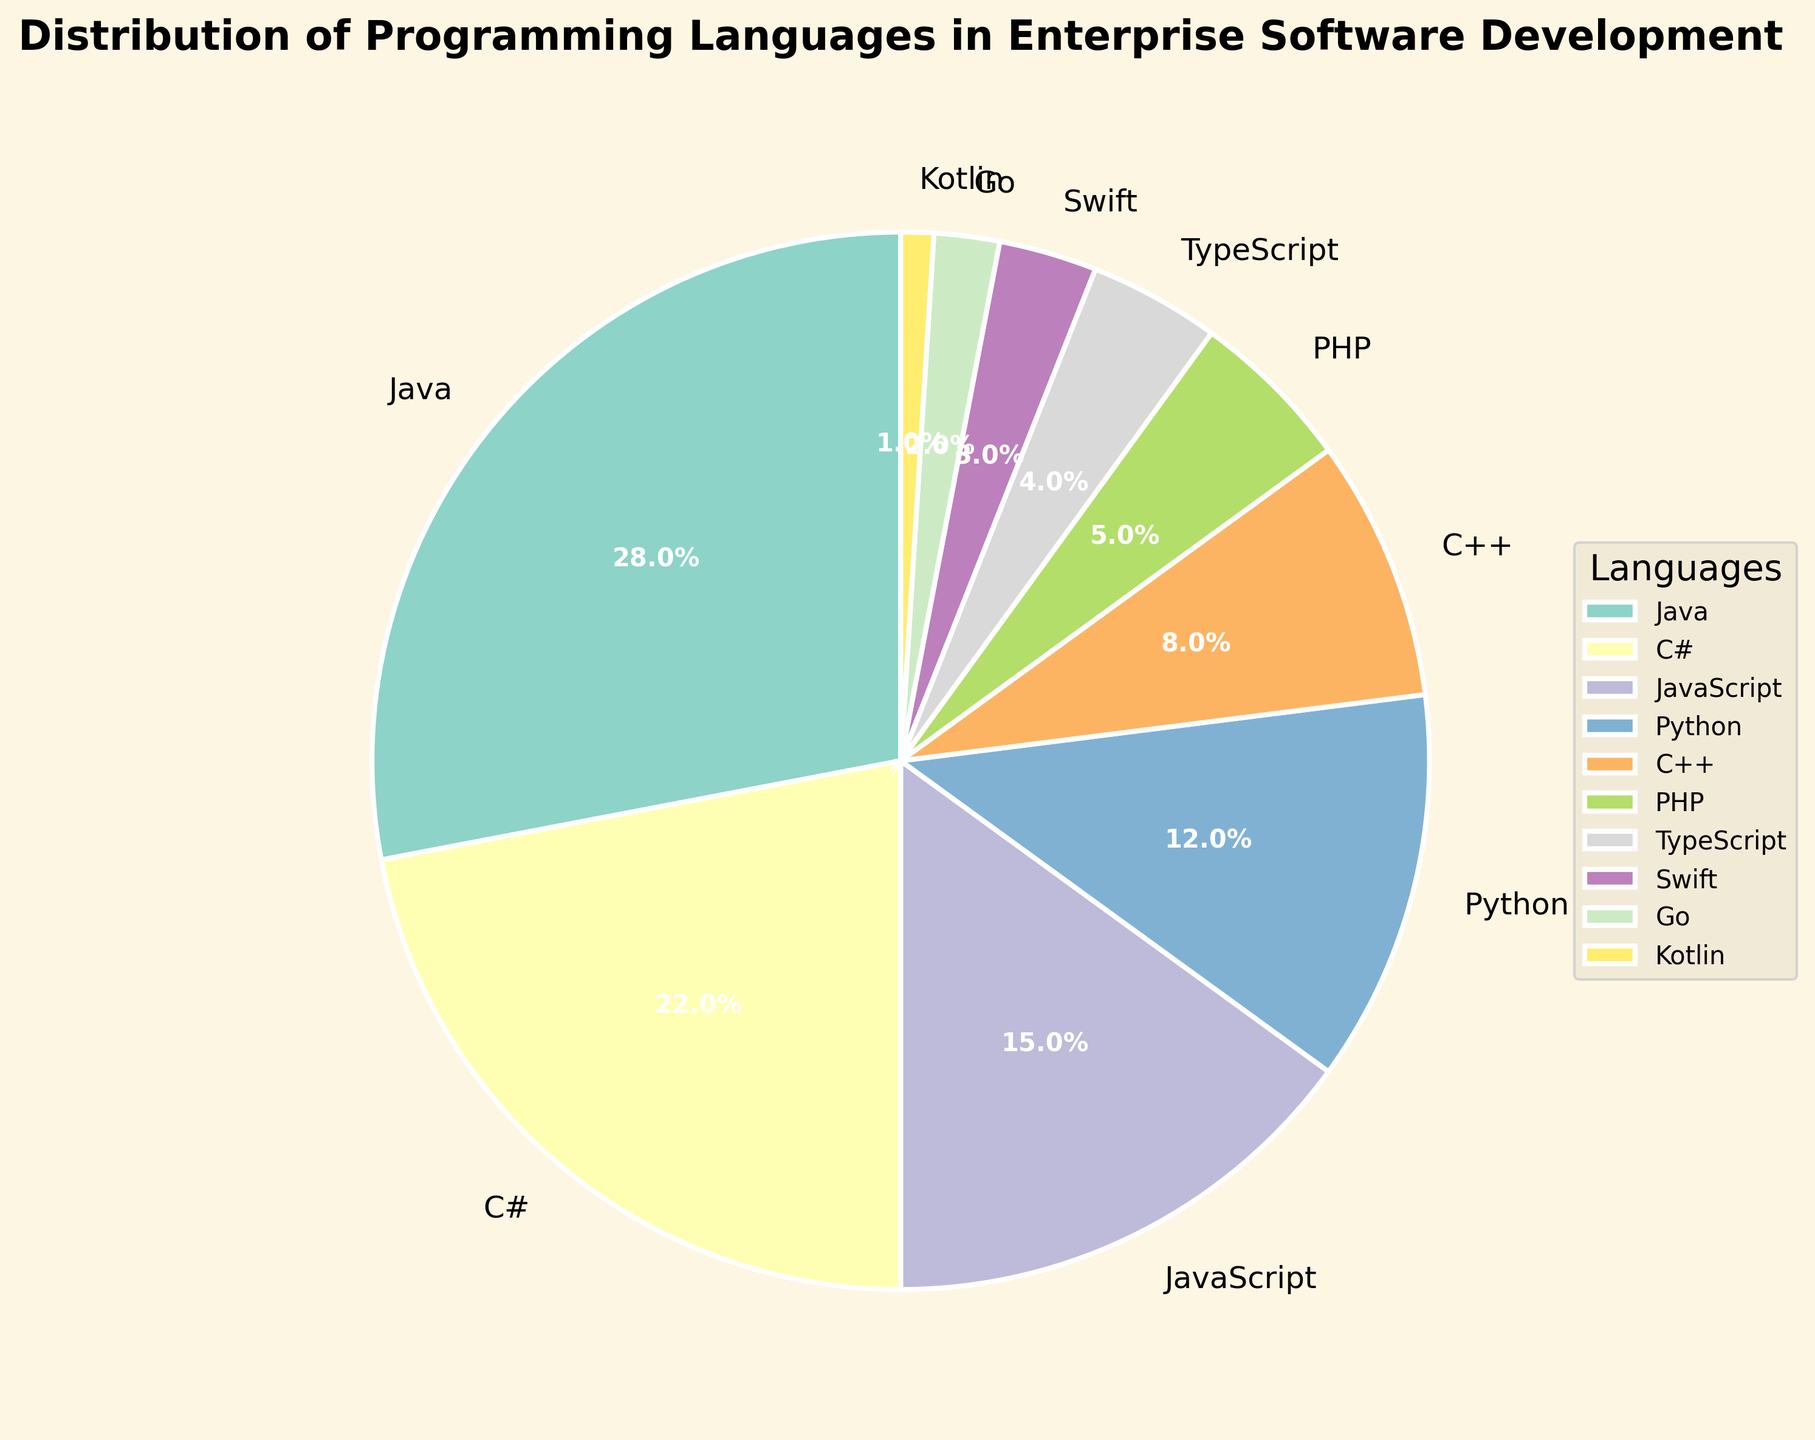What percentage of the distribution is covered by Java and C# combined? The percentages for Java and C# are 28% and 22% respectively. Adding these together, 28% + 22% = 50%
Answer: 50% Which language has the smallest share, and what is that share? Looking at the figure, Kotlin has the smallest share with a percentage of 1%
Answer: Kotlin at 1% Are Python and JavaScript together used more than C#? Python is 12%, and JavaScript is 15%. Adding these together: 12% + 15% = 27%. C# alone is 22%. Since 27% > 22%, Python and JavaScript together are used more than C#
Answer: Yes, 27% vs 22% How does the share of PHP compare to that of Swift and Go combined? PHP is 5%. Swift and Go are 3% and 2% respectively. Adding Swift and Go: 3% + 2% = 5%. Thus, PHP and Swift & Go combined share the same percentage
Answer: Equal Which three languages have the most significant share, and what are their combined percentages? The three languages with the most significant shares are Java (28%), C# (22%), and JavaScript (15%). Combining these: 28% + 22% + 15% = 65%
Answer: Java, C#, JavaScript at 65% If you were to add the shares of Python and C++, would that be more or less than Java? Python is 12%, and C++ is 8%. Adding these together gives 12% + 8% = 20%. Java is 28%, so Python and C++ together would be less than Java
Answer: Less, 20% vs 28% Which slice of the pie has a purple color and what language does it represent? Identifying the colors in the pie chart based on labeling, the slice with purple color could potentially represent Go
Answer: Go How much more is the percentage of Java than TypeScript? Java is 28%, and TypeScript is 4%. Subtracting these gives 28% - 4% = 24%
Answer: 24% What is the total percentage of the languages that are not Java, C#, or JavaScript? The total percentage for all languages is 100%. Excluding Java (28%), C# (22%), and JavaScript (15%), combined these form 28% + 22% + 15% = 65%. Hence, the rest would be 100% - 65% = 35%
Answer: 35% Do PHP and Kotlin together form a higher percentage than C++ alone? PHP is 5%, and Kotlin is 1%, summing these gives 5% + 1% = 6%. C++ alone is 8%. Therefore, PHP and Kotlin together are less than C++
Answer: No, 6% vs 8% 